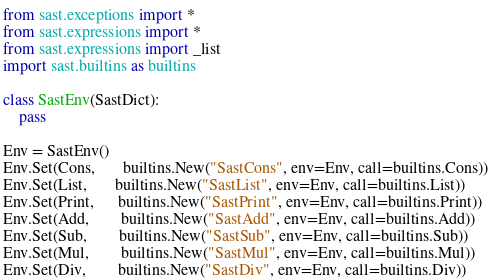<code> <loc_0><loc_0><loc_500><loc_500><_Python_>from sast.exceptions import *
from sast.expressions import *
from sast.expressions import _list
import sast.builtins as builtins

class SastEnv(SastDict):
    pass

Env = SastEnv()
Env.Set(Cons,       builtins.New("SastCons", env=Env, call=builtins.Cons))
Env.Set(List,       builtins.New("SastList", env=Env, call=builtins.List))
Env.Set(Print,      builtins.New("SastPrint", env=Env, call=builtins.Print))
Env.Set(Add,        builtins.New("SastAdd", env=Env, call=builtins.Add))
Env.Set(Sub,        builtins.New("SastSub", env=Env, call=builtins.Sub))
Env.Set(Mul,        builtins.New("SastMul", env=Env, call=builtins.Mul))
Env.Set(Div,        builtins.New("SastDiv", env=Env, call=builtins.Div))
</code> 